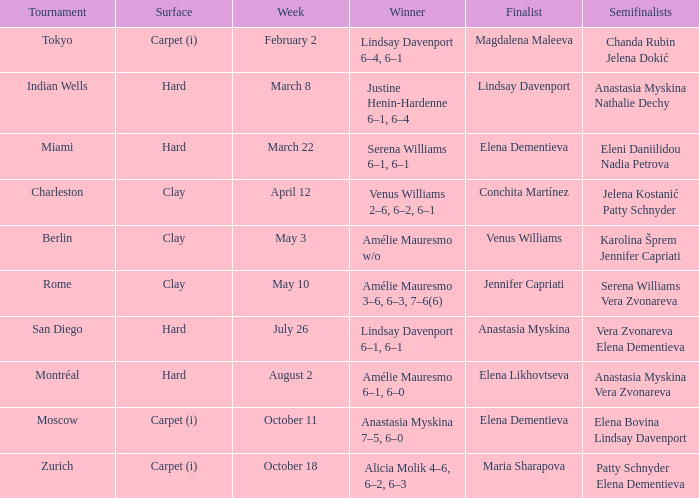Who were the semifinalists in the Rome tournament? Serena Williams Vera Zvonareva. 